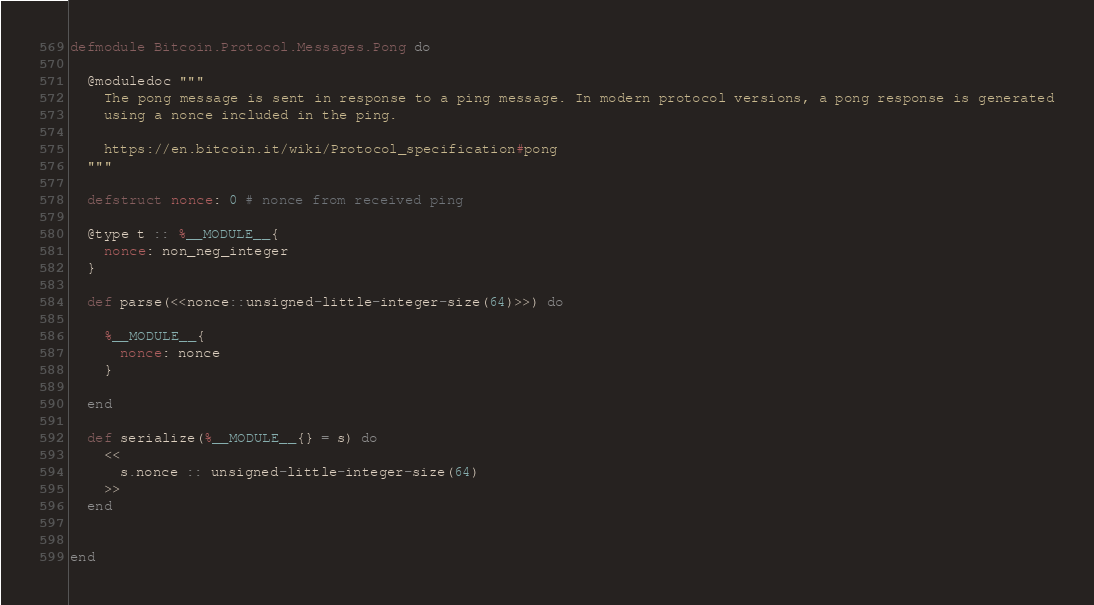<code> <loc_0><loc_0><loc_500><loc_500><_Elixir_>defmodule Bitcoin.Protocol.Messages.Pong do

  @moduledoc """
    The pong message is sent in response to a ping message. In modern protocol versions, a pong response is generated
    using a nonce included in the ping.

    https://en.bitcoin.it/wiki/Protocol_specification#pong
  """

  defstruct nonce: 0 # nonce from received ping

  @type t :: %__MODULE__{
    nonce: non_neg_integer
  }

  def parse(<<nonce::unsigned-little-integer-size(64)>>) do

    %__MODULE__{
      nonce: nonce
    }

  end

  def serialize(%__MODULE__{} = s) do
    <<
      s.nonce :: unsigned-little-integer-size(64)
    >>
  end


end
</code> 